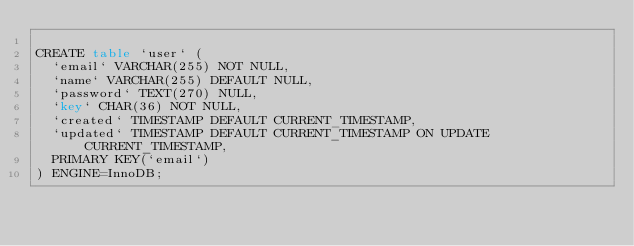<code> <loc_0><loc_0><loc_500><loc_500><_SQL_>
CREATE table `user` (
  `email` VARCHAR(255) NOT NULL,
  `name` VARCHAR(255) DEFAULT NULL,
  `password` TEXT(270) NULL,
  `key` CHAR(36) NOT NULL,
  `created` TIMESTAMP DEFAULT CURRENT_TIMESTAMP,
  `updated` TIMESTAMP DEFAULT CURRENT_TIMESTAMP ON UPDATE CURRENT_TIMESTAMP,
  PRIMARY KEY(`email`)
) ENGINE=InnoDB;
</code> 